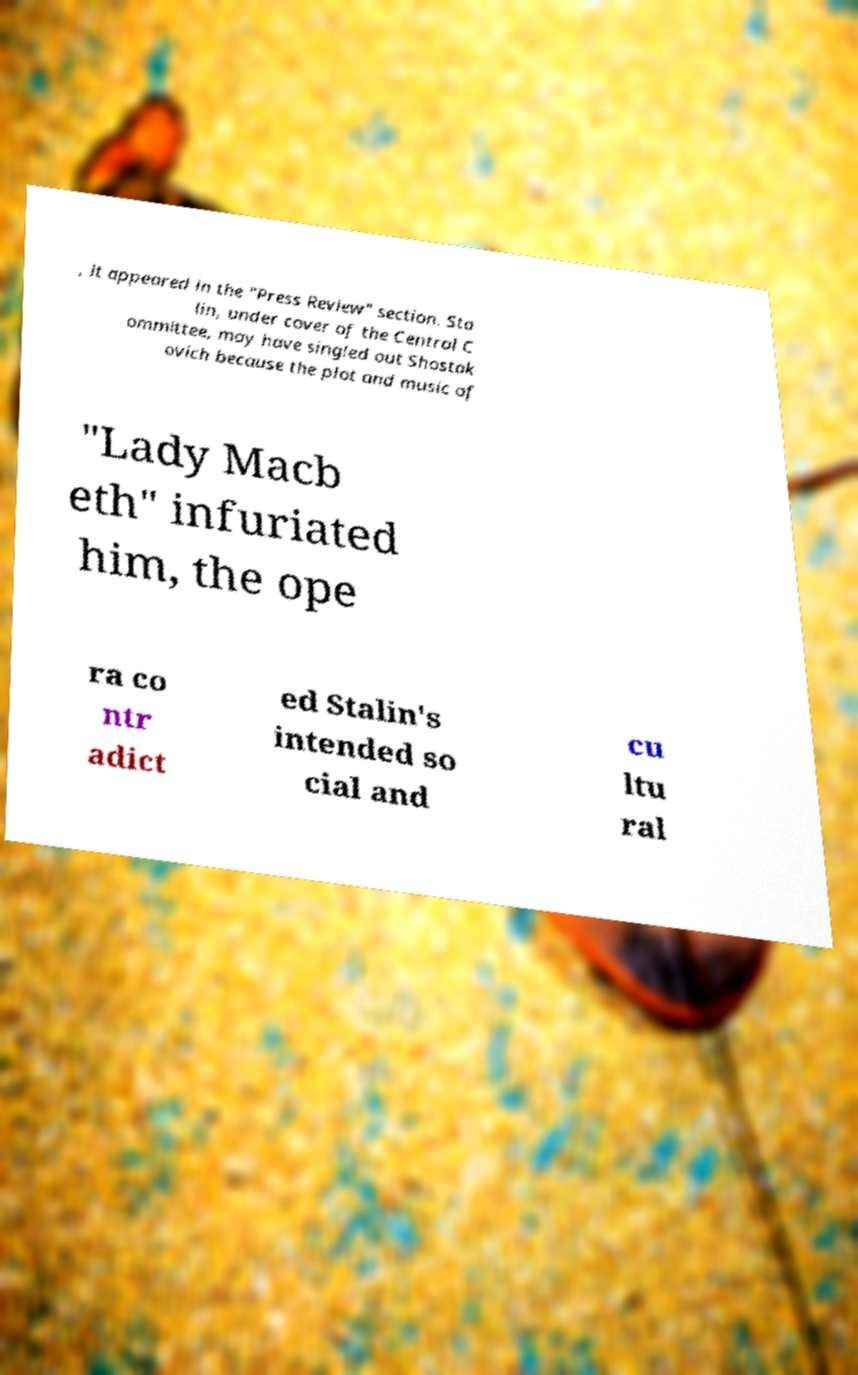For documentation purposes, I need the text within this image transcribed. Could you provide that? , it appeared in the "Press Review" section. Sta lin, under cover of the Central C ommittee, may have singled out Shostak ovich because the plot and music of "Lady Macb eth" infuriated him, the ope ra co ntr adict ed Stalin's intended so cial and cu ltu ral 